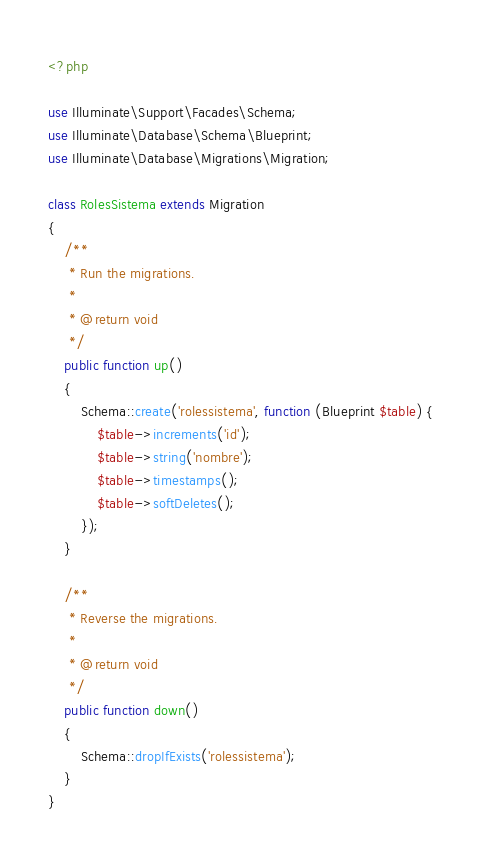Convert code to text. <code><loc_0><loc_0><loc_500><loc_500><_PHP_><?php

use Illuminate\Support\Facades\Schema;
use Illuminate\Database\Schema\Blueprint;
use Illuminate\Database\Migrations\Migration;

class RolesSistema extends Migration
{
    /**
     * Run the migrations.
     *
     * @return void
     */
    public function up()
    {
        Schema::create('rolessistema', function (Blueprint $table) {
            $table->increments('id');
            $table->string('nombre');
            $table->timestamps();
            $table->softDeletes();
        });
    }

    /**
     * Reverse the migrations.
     *
     * @return void
     */
    public function down()
    {
        Schema::dropIfExists('rolessistema');
    }
}
</code> 